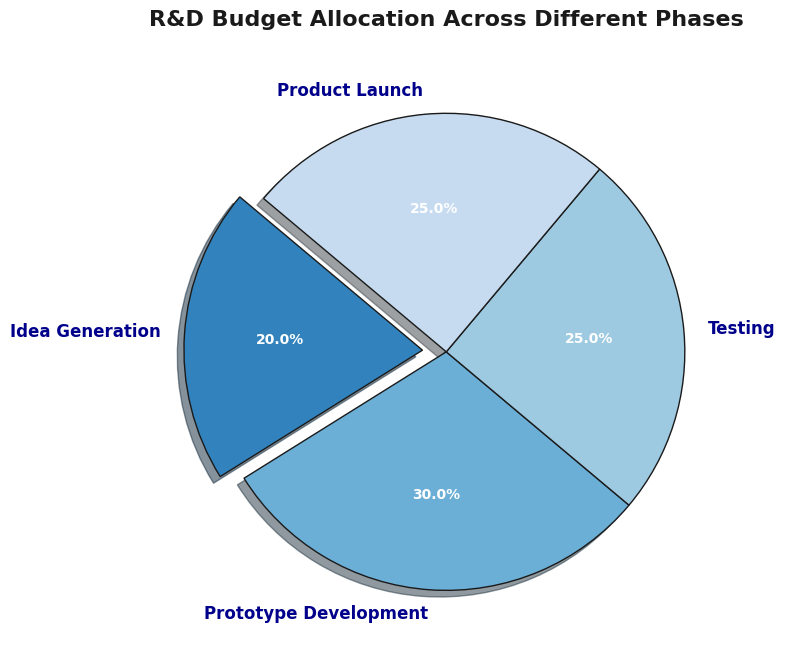Which phase in the R&D process has the smallest budget allocation percentage? To find the phase with the smallest budget allocation, look at the pie chart slices and their corresponding percentage labels. The slice labeled "Idea Generation" has the smallest percentage allocation at 20%.
Answer: Idea Generation What is the combined budget allocation percentage for Testing and Product Launch? Add the percentages of Testing and Product Launch. Testing has 25% and Product Launch has 25%, so 25% + 25% equals 50%.
Answer: 50% Which phase has a higher budget allocation: Prototype Development or Testing? Compare the percentages of the two phases. Prototype Development has 30%, while Testing has 25%. Since 30% is greater than 25%, Prototype Development has a higher budget allocation.
Answer: Prototype Development How much more budget allocation percentage does Prototype Development have compared to Idea Generation? Subtract the percentage of Idea Generation from Prototype Development. Prototype Development has 30% and Idea Generation has 20%. So, 30% - 20% equals 10%.
Answer: 10% Is the budget allocation for Product Launch equal to that of Testing? Observe the pie chart slices and their respective percentages. Both Product Launch and Testing have slices labeled with 25%. Therefore, they have equal budget allocation percentages.
Answer: Yes Which phase is visually emphasized in the pie chart, and how is it emphasized? Look for visual cues in the pie chart like highlighted or separated slices. The phase "Idea Generation" is visually emphasized as its slice is separated from the rest of the pie (exploded).
Answer: Idea Generation What is the total budget allocation percentage for the phases that are not Idea Generation? Subtract the Idea Generation percentage from 100%. Idea Generation has 20%, so the remaining phases have 100% - 20% = 80%.
Answer: 80% Between Product Launch and Idea Generation, which phase has a smaller budget allocation, and by how much? Compare the budget allocation percentages of both phases. Idea Generation has 20%, and Product Launch has 25%. Subtract 20% from 25% to get the difference of 5%.
Answer: Idea Generation, by 5% What proportion of the total budget is allocated to Prototype Development in comparison to the remaining phases? Calculate the proportion by dividing the allocation of Prototype Development by the sum of the allocations for Testing, Product Launch, and Idea Generation. Prototype Development has 30%, while the sum of the remaining phases is 25% + 25% + 20% = 70%. Therefore, the proportion is 30% / 70% = 3/7 or approximately 0.43.
Answer: approximately 0.43 